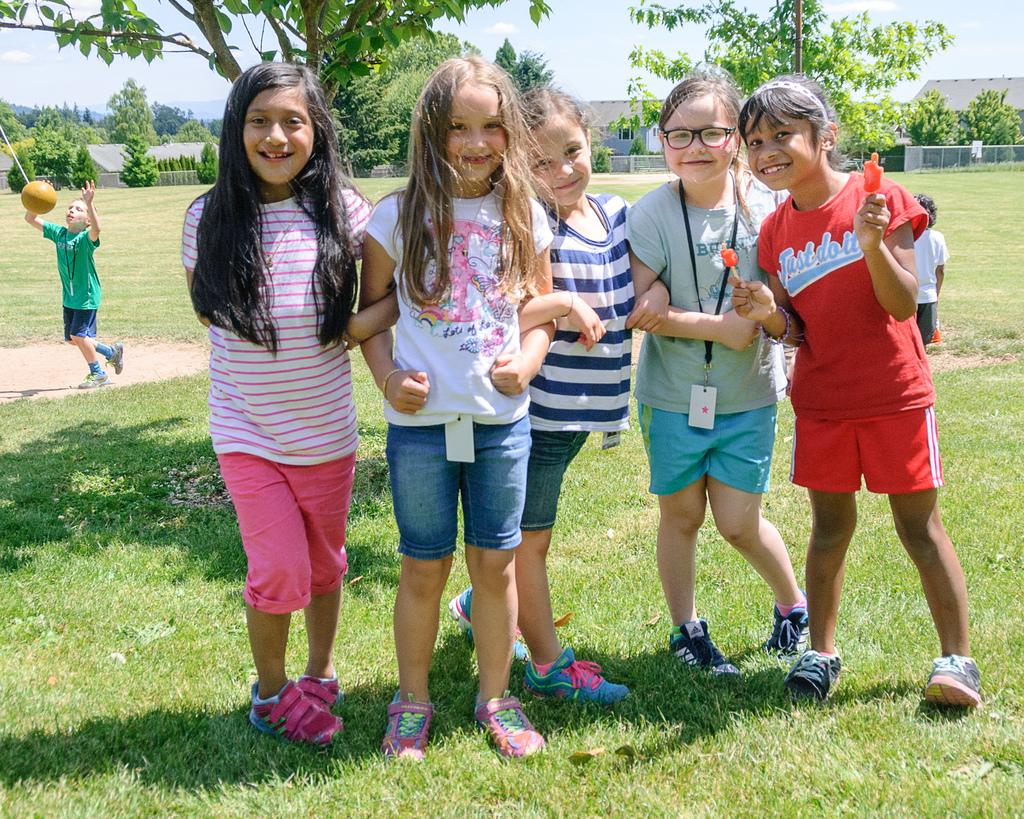How many girls are in the image? There are five girls standing on the grassy land. What is the boy in the background doing? The boy is playing with a ball in the background. What can be seen in the background besides the boy? Trees are present in the background. What type of flight is the boy taking in the image? There is no flight present in the image; the boy is playing with a ball. How many geese are flying in the image? There are no geese present in the image. 